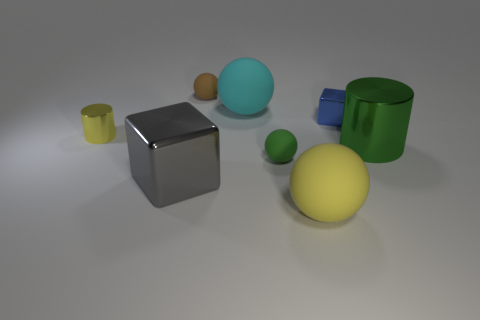Do the small thing behind the blue shiny thing and the big cyan object have the same material?
Your answer should be compact. Yes. What number of things are to the left of the tiny cube and behind the gray cube?
Offer a terse response. 4. What size is the cube that is to the left of the cube that is to the right of the brown ball?
Your answer should be compact. Large. Are there any other things that are the same material as the yellow ball?
Your answer should be compact. Yes. Are there more tiny brown rubber spheres than tiny spheres?
Keep it short and to the point. No. Do the small sphere that is to the right of the tiny brown thing and the big sphere that is behind the tiny cylinder have the same color?
Give a very brief answer. No. There is a cube that is behind the gray object; are there any matte things that are behind it?
Offer a very short reply. Yes. Is the number of small blue shiny objects in front of the large yellow matte sphere less than the number of small green things that are right of the blue object?
Make the answer very short. No. Do the large object that is behind the large green metallic object and the cylinder left of the big gray metallic block have the same material?
Give a very brief answer. No. How many tiny things are green metal spheres or brown matte objects?
Your answer should be very brief. 1. 